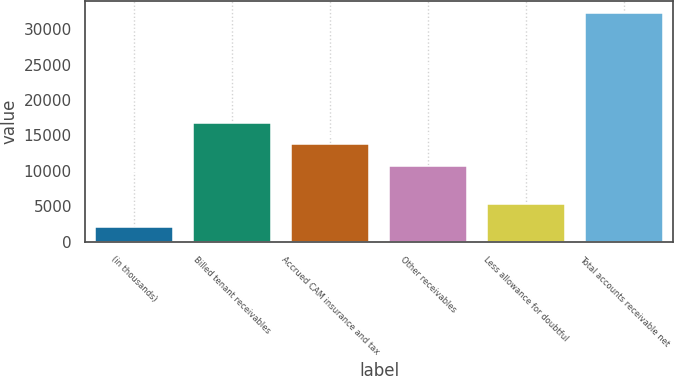Convert chart to OTSL. <chart><loc_0><loc_0><loc_500><loc_500><bar_chart><fcel>(in thousands)<fcel>Billed tenant receivables<fcel>Accrued CAM insurance and tax<fcel>Other receivables<fcel>Less allowance for doubtful<fcel>Total accounts receivable net<nl><fcel>2015<fcel>16763.4<fcel>13735.7<fcel>10708<fcel>5295<fcel>32292<nl></chart> 